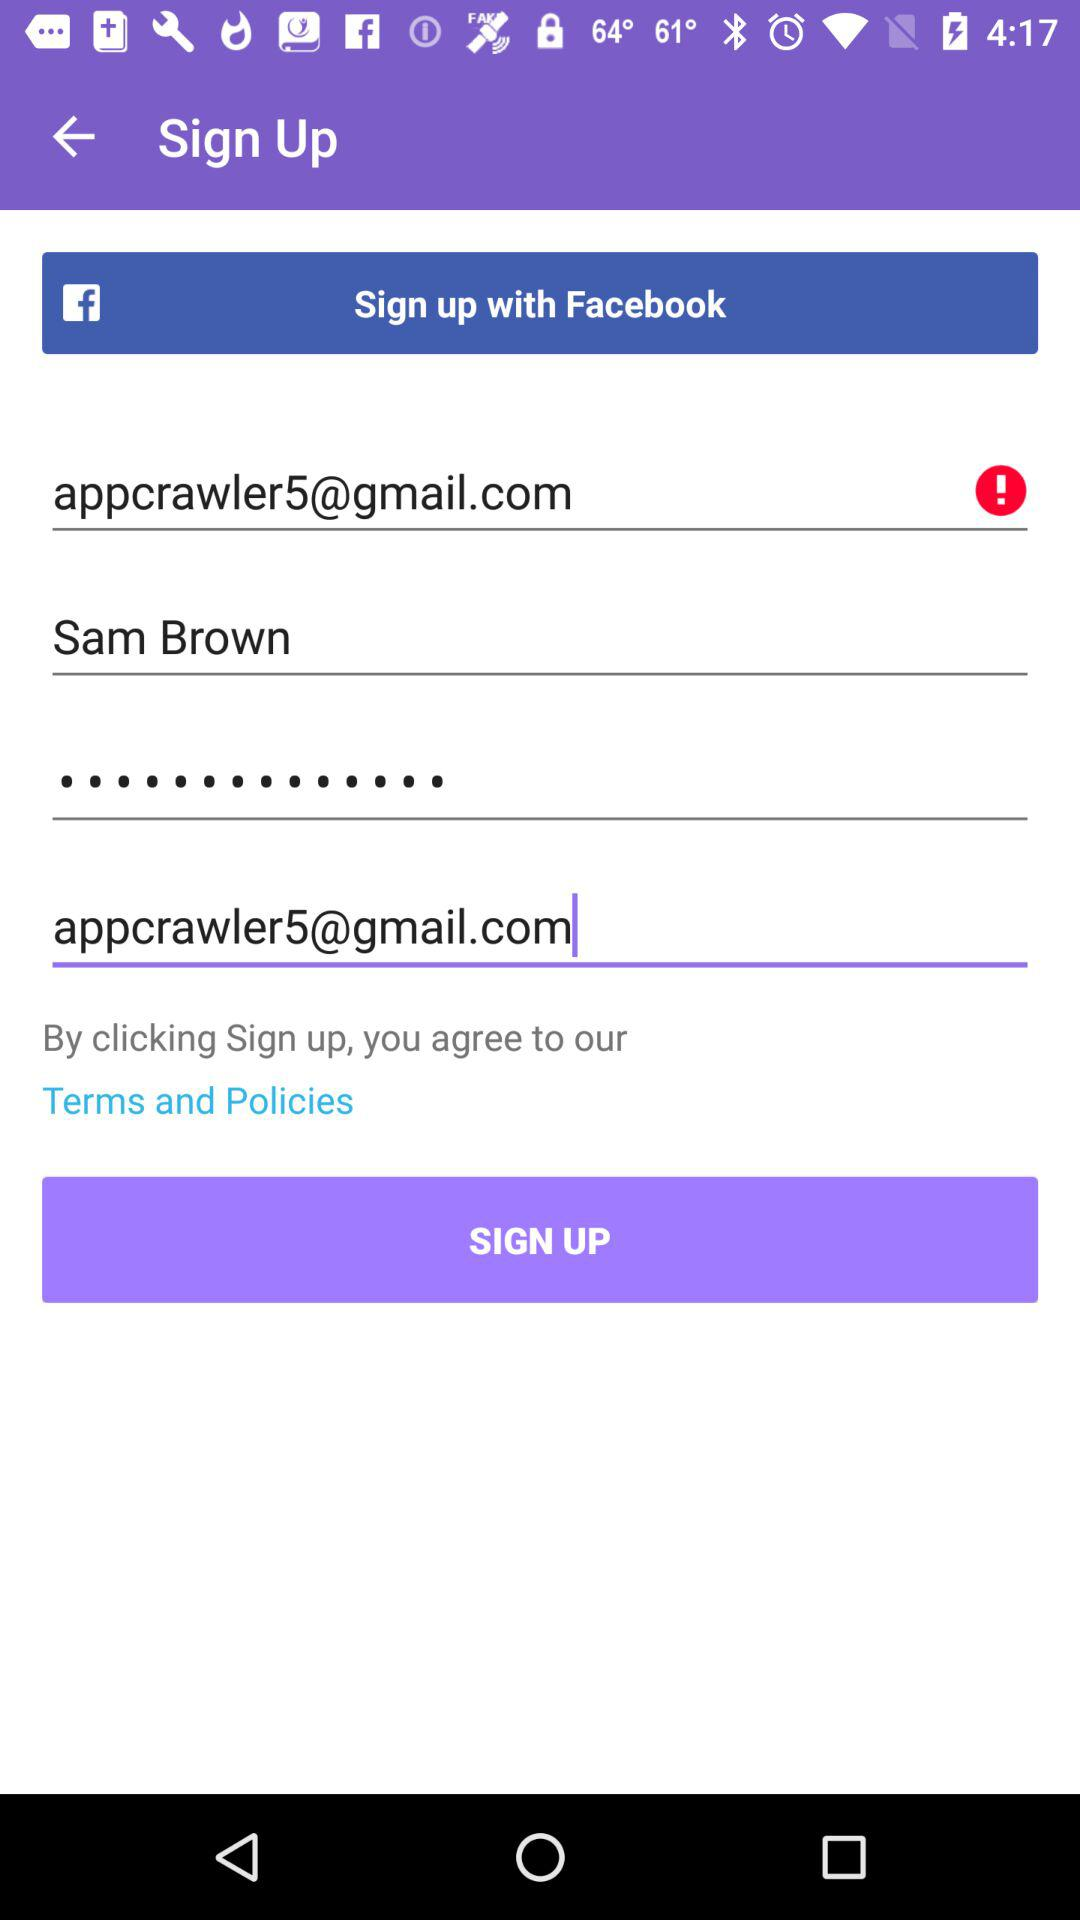What's the Gmail address? The Gmail address is appcrawler5@gmail.com. 